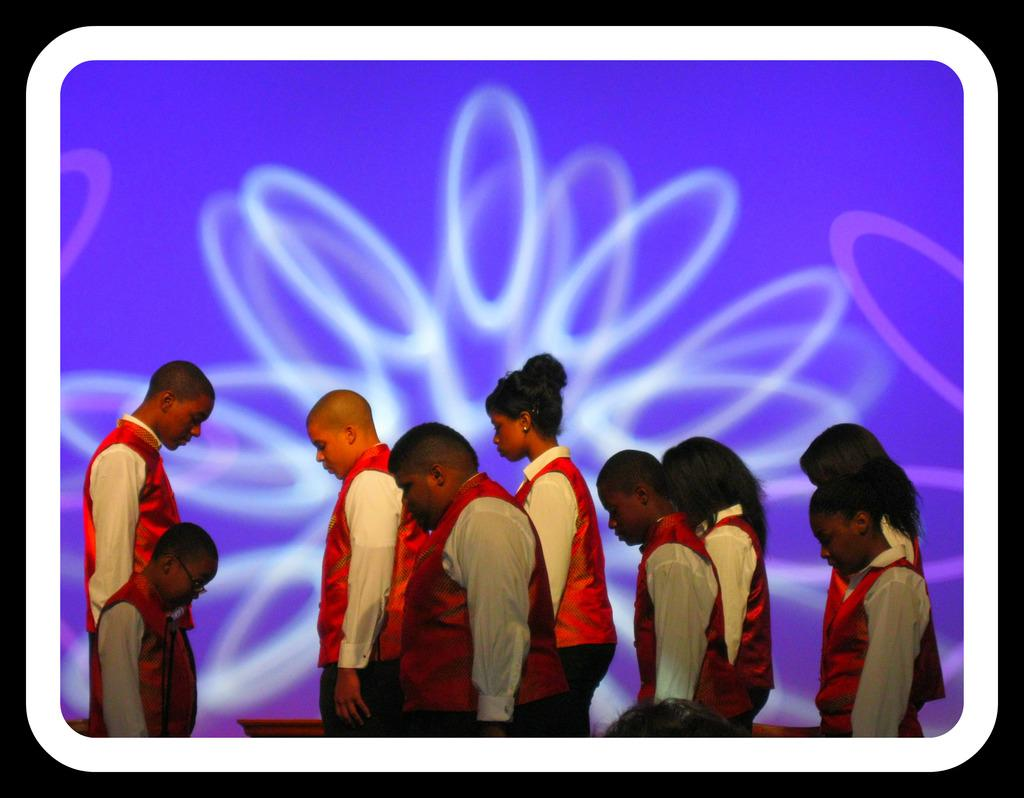How many people are in the image? There is a group of persons standing in the image. Where are the persons located in the image? The group of persons is at the bottom of the image. What color is the wall in the background of the image? There is a blue color wall in the background of the image. What can be observed on the blue wall? The blue color wall has some design on it. What type of board is being used to cause a disturbance on the farm in the image? There is no board, cause, or farm present in the image. 